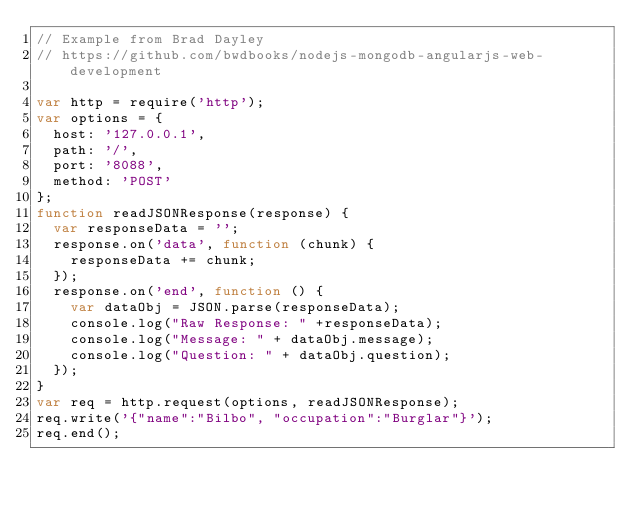<code> <loc_0><loc_0><loc_500><loc_500><_JavaScript_>// Example from Brad Dayley
// https://github.com/bwdbooks/nodejs-mongodb-angularjs-web-development

var http = require('http');
var options = {
  host: '127.0.0.1',
  path: '/',
  port: '8088',
  method: 'POST'
};
function readJSONResponse(response) {
  var responseData = '';
  response.on('data', function (chunk) {
    responseData += chunk;
  });  
  response.on('end', function () {
    var dataObj = JSON.parse(responseData);
    console.log("Raw Response: " +responseData);
    console.log("Message: " + dataObj.message);
    console.log("Question: " + dataObj.question);
  });
}
var req = http.request(options, readJSONResponse);
req.write('{"name":"Bilbo", "occupation":"Burglar"}');
req.end();
</code> 